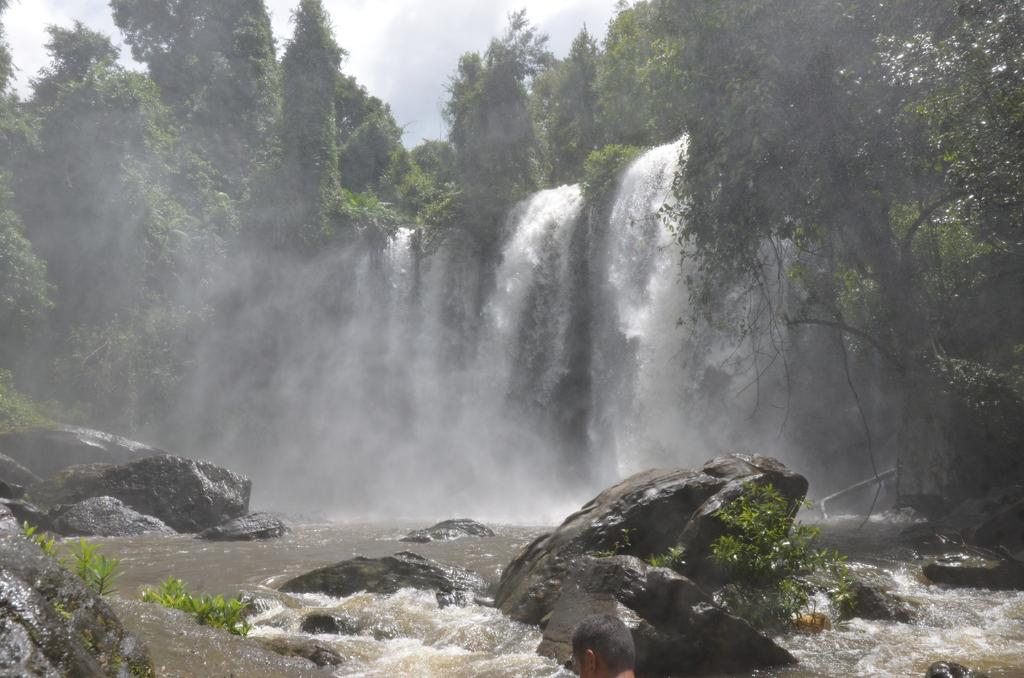What can be seen in the sky in the image? The sky with clouds is visible in the image. What type of vegetation is present in the image? There are trees in the image. What type of plant is present that is climbing or hanging? Creepers are present in the image. What natural feature can be seen in the image? There is a waterfall in the image. What type of geological formation is visible in the image? Rocks are visible in the image. What type of wine is being served at the father's ring ceremony in the image? There is no reference to a father, wine, or ring ceremony in the image; it features natural elements such as the sky, trees, creepers, a waterfall, and rocks. 